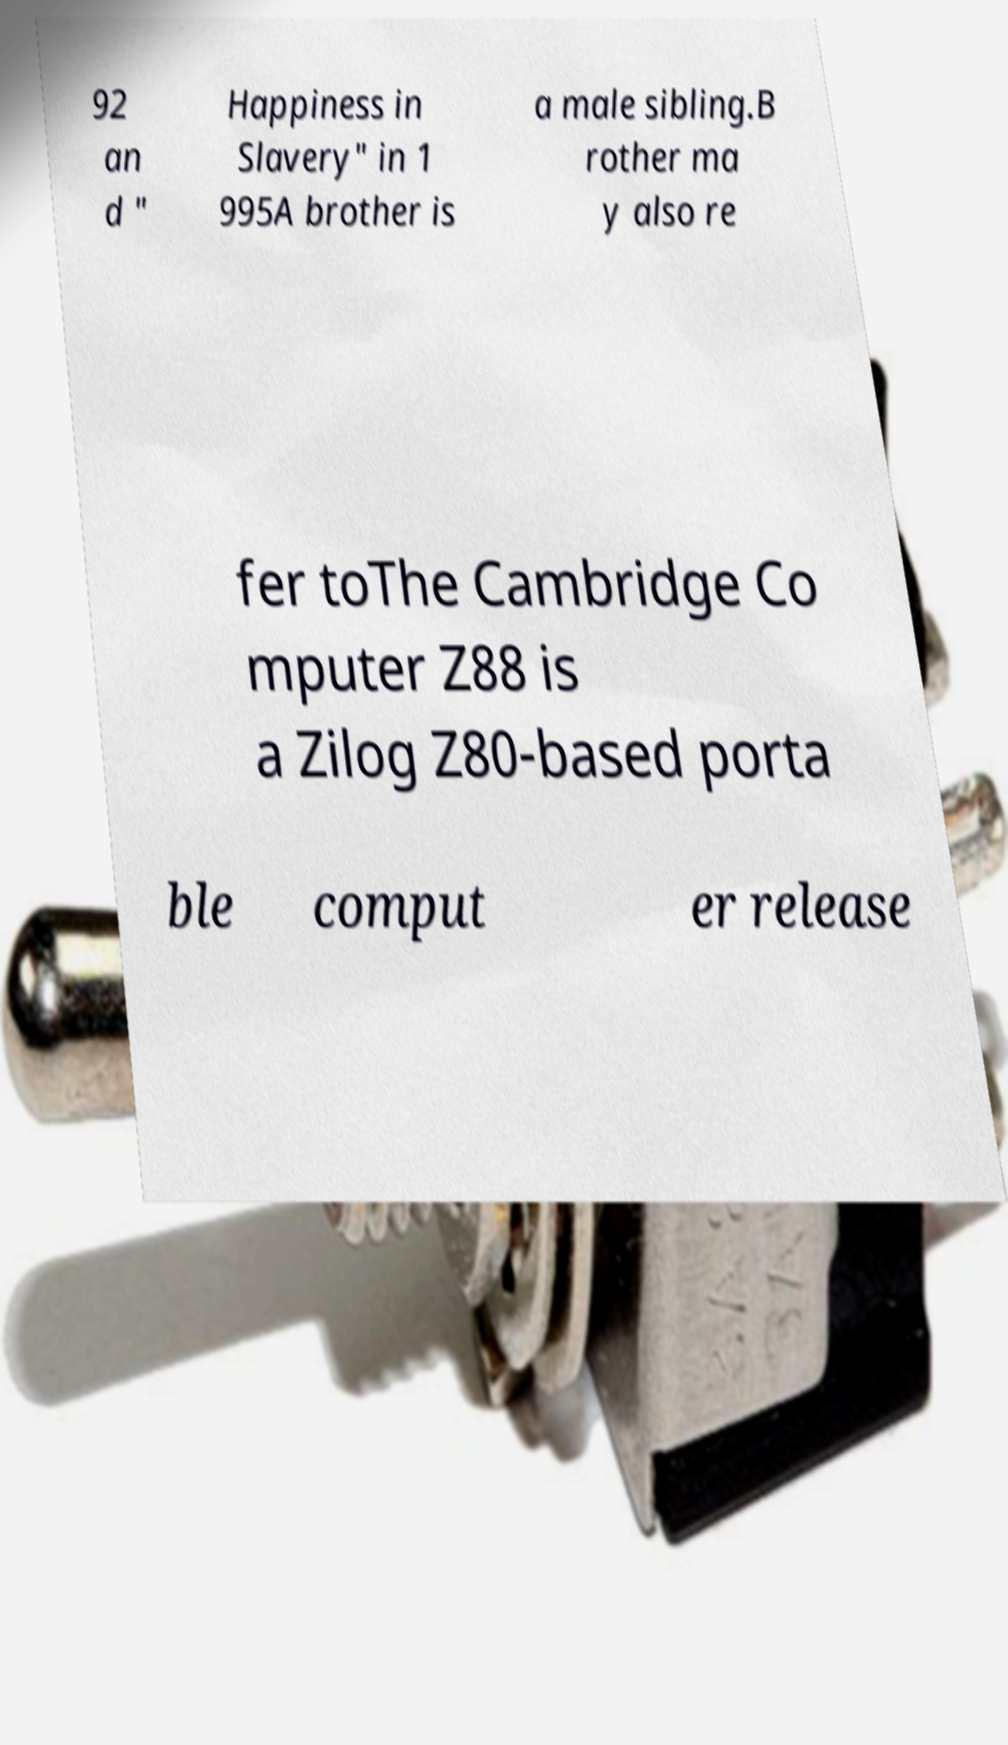Please identify and transcribe the text found in this image. 92 an d " Happiness in Slavery" in 1 995A brother is a male sibling.B rother ma y also re fer toThe Cambridge Co mputer Z88 is a Zilog Z80-based porta ble comput er release 